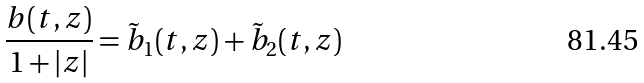Convert formula to latex. <formula><loc_0><loc_0><loc_500><loc_500>\frac { b ( t , z ) } { 1 + | z | } = \tilde { b } _ { 1 } ( t , z ) + \tilde { b } _ { 2 } ( t , z )</formula> 